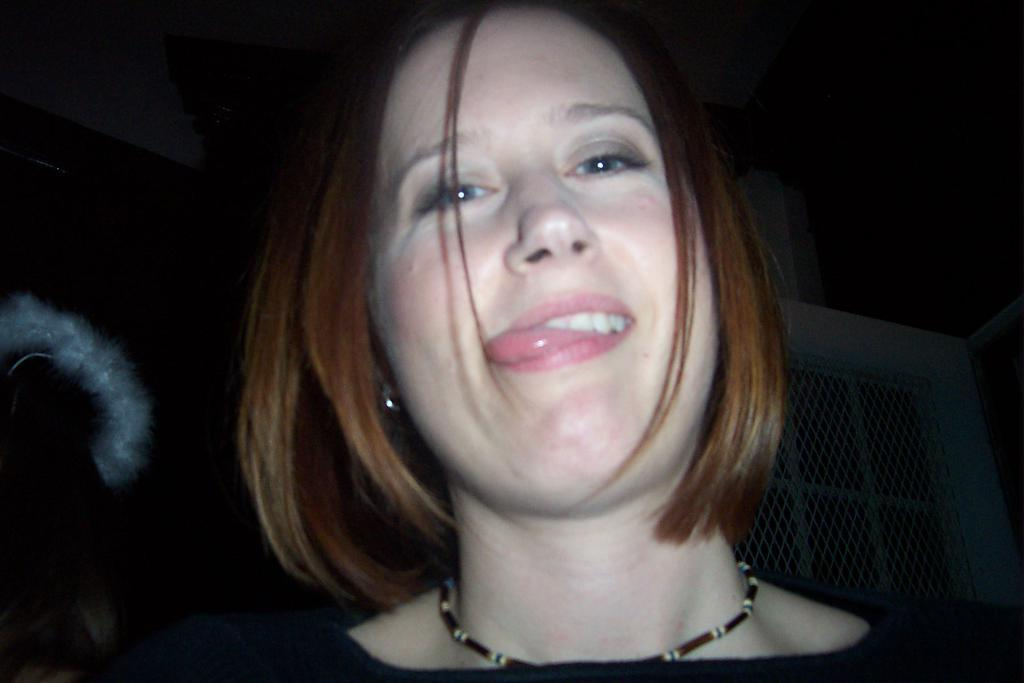Who is present in the image? There is a lady in the image. What is behind the lady? There is a mesh door behind the lady. How would you describe the overall lighting in the image? The background of the image is dark. What type of marble is visible on the floor in the image? There is no marble visible on the floor in the image. 